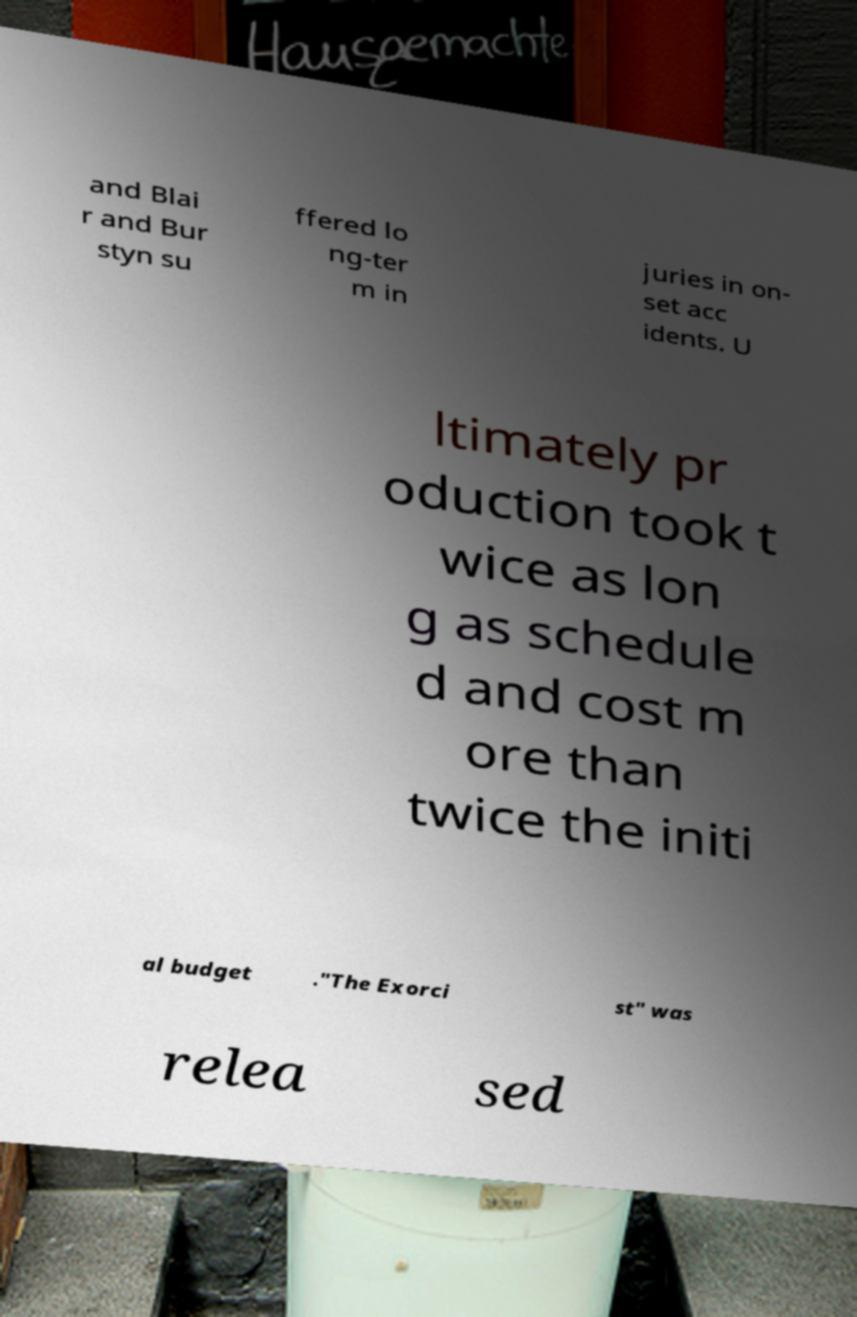I need the written content from this picture converted into text. Can you do that? and Blai r and Bur styn su ffered lo ng-ter m in juries in on- set acc idents. U ltimately pr oduction took t wice as lon g as schedule d and cost m ore than twice the initi al budget ."The Exorci st" was relea sed 